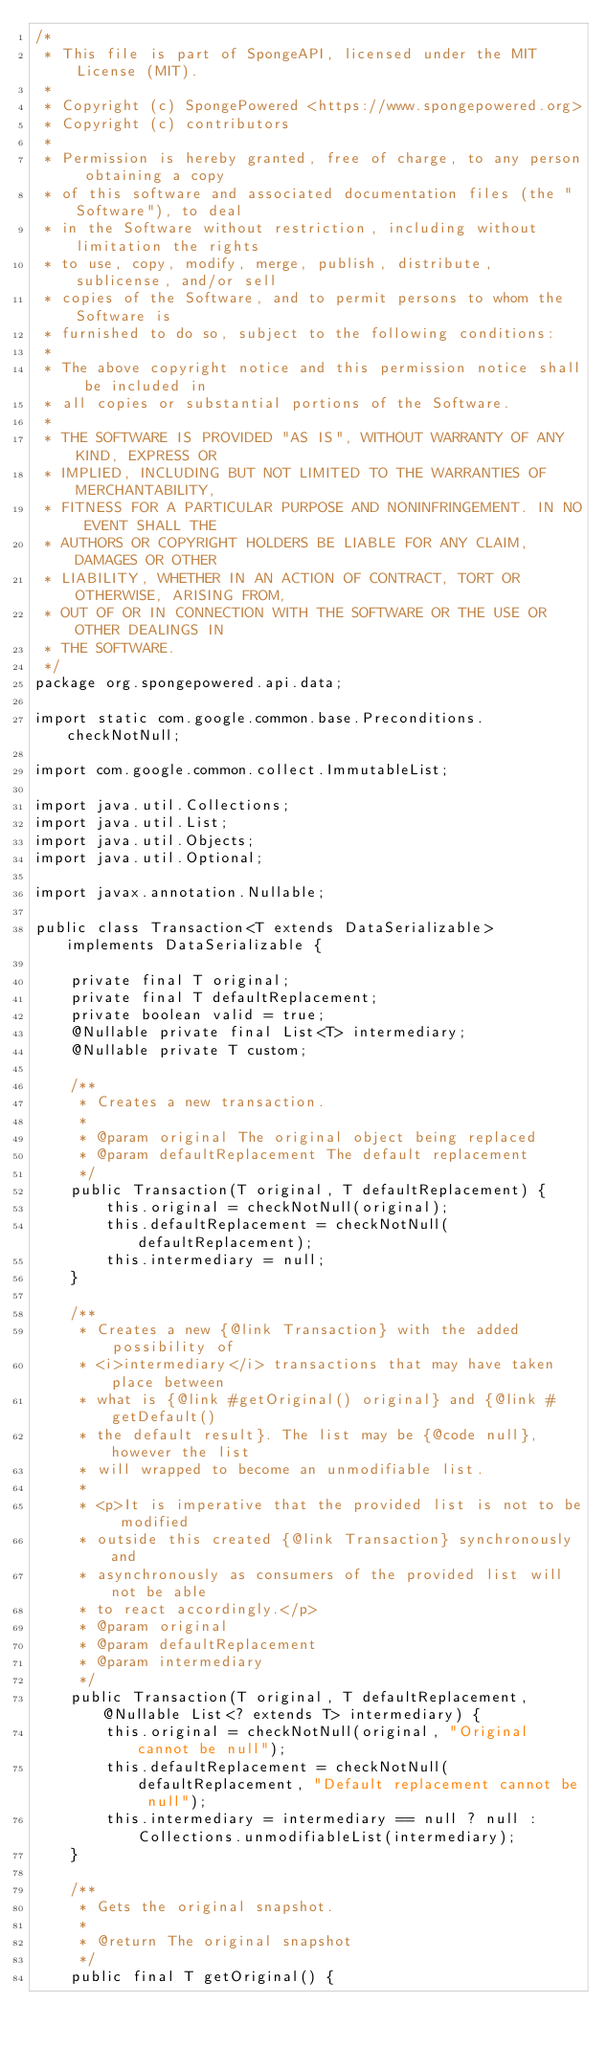Convert code to text. <code><loc_0><loc_0><loc_500><loc_500><_Java_>/*
 * This file is part of SpongeAPI, licensed under the MIT License (MIT).
 *
 * Copyright (c) SpongePowered <https://www.spongepowered.org>
 * Copyright (c) contributors
 *
 * Permission is hereby granted, free of charge, to any person obtaining a copy
 * of this software and associated documentation files (the "Software"), to deal
 * in the Software without restriction, including without limitation the rights
 * to use, copy, modify, merge, publish, distribute, sublicense, and/or sell
 * copies of the Software, and to permit persons to whom the Software is
 * furnished to do so, subject to the following conditions:
 *
 * The above copyright notice and this permission notice shall be included in
 * all copies or substantial portions of the Software.
 *
 * THE SOFTWARE IS PROVIDED "AS IS", WITHOUT WARRANTY OF ANY KIND, EXPRESS OR
 * IMPLIED, INCLUDING BUT NOT LIMITED TO THE WARRANTIES OF MERCHANTABILITY,
 * FITNESS FOR A PARTICULAR PURPOSE AND NONINFRINGEMENT. IN NO EVENT SHALL THE
 * AUTHORS OR COPYRIGHT HOLDERS BE LIABLE FOR ANY CLAIM, DAMAGES OR OTHER
 * LIABILITY, WHETHER IN AN ACTION OF CONTRACT, TORT OR OTHERWISE, ARISING FROM,
 * OUT OF OR IN CONNECTION WITH THE SOFTWARE OR THE USE OR OTHER DEALINGS IN
 * THE SOFTWARE.
 */
package org.spongepowered.api.data;

import static com.google.common.base.Preconditions.checkNotNull;

import com.google.common.collect.ImmutableList;

import java.util.Collections;
import java.util.List;
import java.util.Objects;
import java.util.Optional;

import javax.annotation.Nullable;

public class Transaction<T extends DataSerializable> implements DataSerializable {

    private final T original;
    private final T defaultReplacement;
    private boolean valid = true;
    @Nullable private final List<T> intermediary;
    @Nullable private T custom;

    /**
     * Creates a new transaction.
     *
     * @param original The original object being replaced
     * @param defaultReplacement The default replacement
     */
    public Transaction(T original, T defaultReplacement) {
        this.original = checkNotNull(original);
        this.defaultReplacement = checkNotNull(defaultReplacement);
        this.intermediary = null;
    }

    /**
     * Creates a new {@link Transaction} with the added possibility of
     * <i>intermediary</i> transactions that may have taken place between
     * what is {@link #getOriginal() original} and {@link #getDefault()
     * the default result}. The list may be {@code null}, however the list
     * will wrapped to become an unmodifiable list.
     *
     * <p>It is imperative that the provided list is not to be modified
     * outside this created {@link Transaction} synchronously and
     * asynchronously as consumers of the provided list will not be able
     * to react accordingly.</p>
     * @param original
     * @param defaultReplacement
     * @param intermediary
     */
    public Transaction(T original, T defaultReplacement, @Nullable List<? extends T> intermediary) {
        this.original = checkNotNull(original, "Original cannot be null");
        this.defaultReplacement = checkNotNull(defaultReplacement, "Default replacement cannot be null");
        this.intermediary = intermediary == null ? null : Collections.unmodifiableList(intermediary);
    }

    /**
     * Gets the original snapshot.
     *
     * @return The original snapshot
     */
    public final T getOriginal() {</code> 